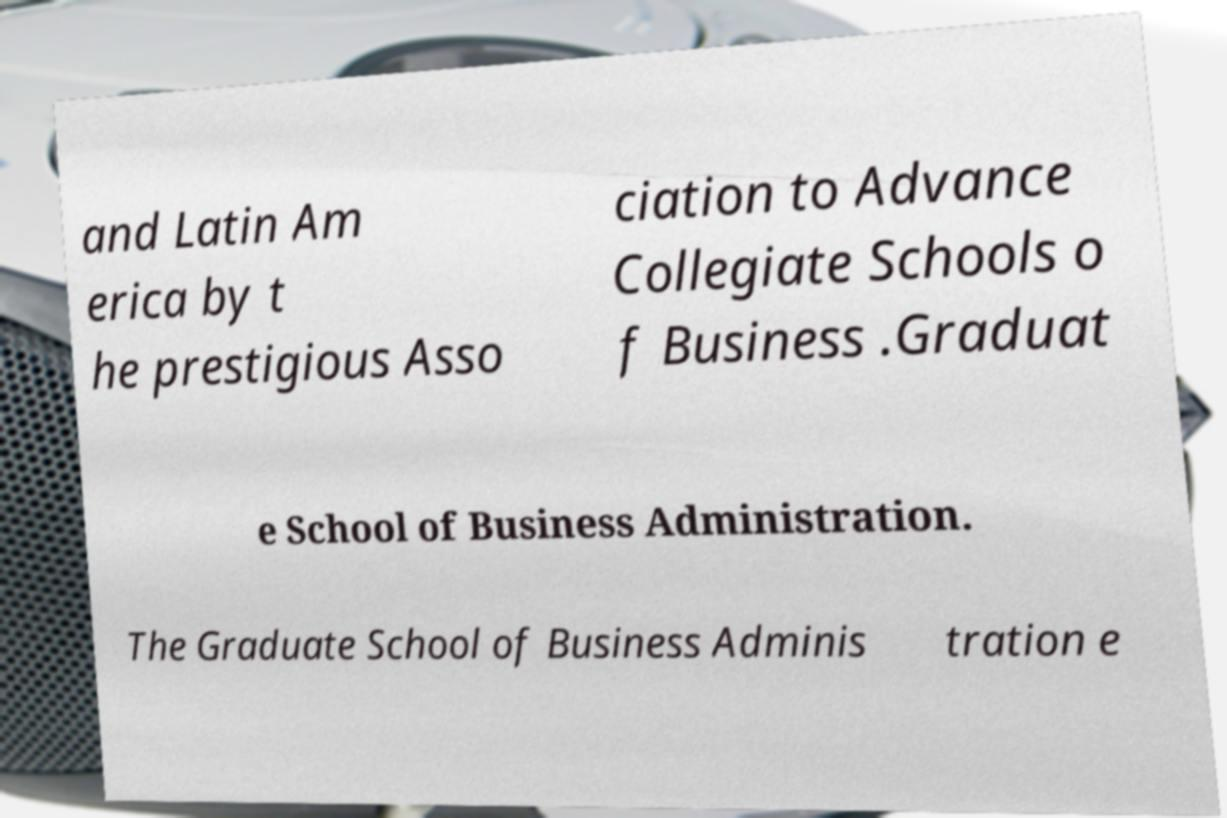Please identify and transcribe the text found in this image. and Latin Am erica by t he prestigious Asso ciation to Advance Collegiate Schools o f Business .Graduat e School of Business Administration. The Graduate School of Business Adminis tration e 